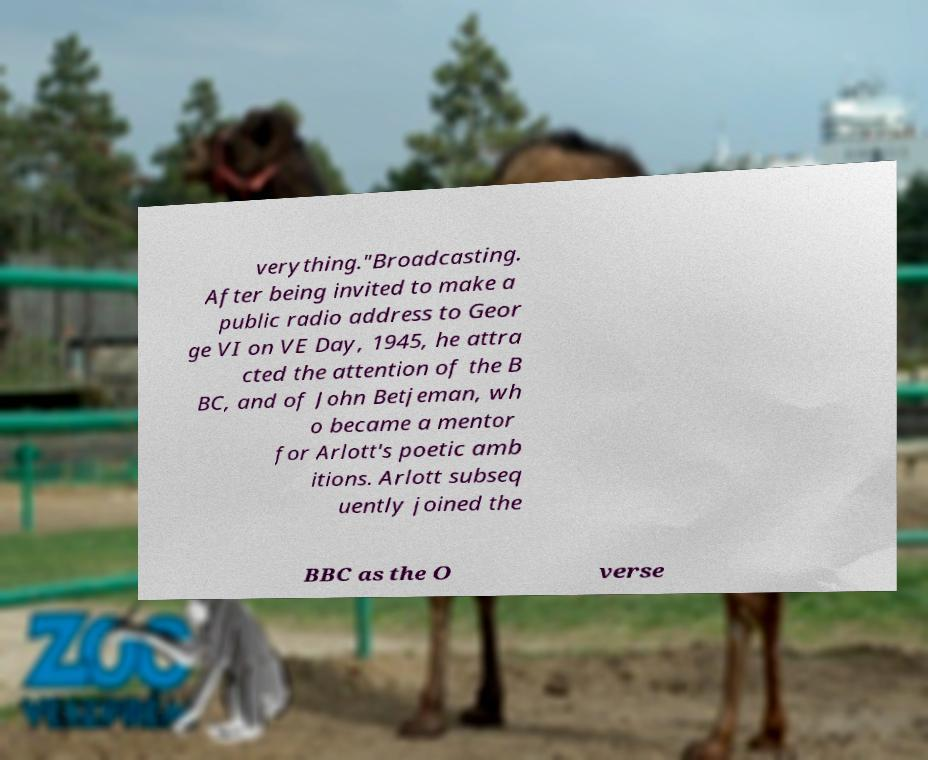Could you assist in decoding the text presented in this image and type it out clearly? verything."Broadcasting. After being invited to make a public radio address to Geor ge VI on VE Day, 1945, he attra cted the attention of the B BC, and of John Betjeman, wh o became a mentor for Arlott's poetic amb itions. Arlott subseq uently joined the BBC as the O verse 